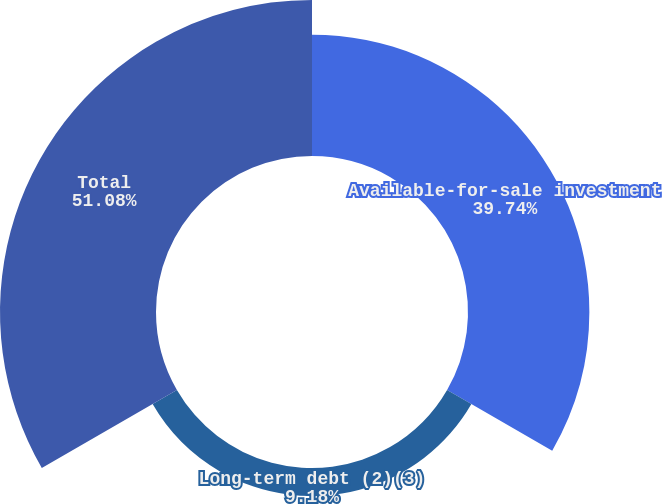<chart> <loc_0><loc_0><loc_500><loc_500><pie_chart><fcel>Available-for-sale investment<fcel>Long-term debt (2)(3)<fcel>Total<nl><fcel>39.74%<fcel>9.18%<fcel>51.08%<nl></chart> 